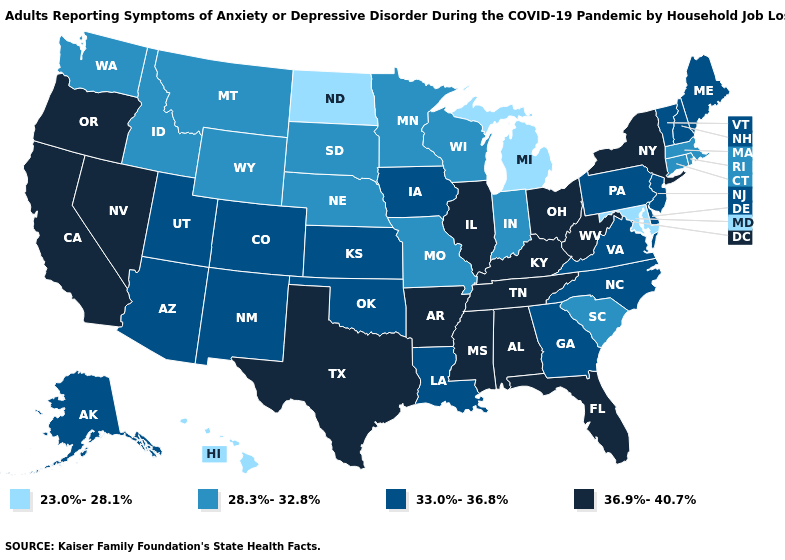Which states have the lowest value in the USA?
Quick response, please. Hawaii, Maryland, Michigan, North Dakota. What is the highest value in the South ?
Write a very short answer. 36.9%-40.7%. What is the value of New Mexico?
Keep it brief. 33.0%-36.8%. What is the value of Illinois?
Short answer required. 36.9%-40.7%. Which states hav the highest value in the West?
Quick response, please. California, Nevada, Oregon. Does Hawaii have the lowest value in the USA?
Give a very brief answer. Yes. Name the states that have a value in the range 33.0%-36.8%?
Keep it brief. Alaska, Arizona, Colorado, Delaware, Georgia, Iowa, Kansas, Louisiana, Maine, New Hampshire, New Jersey, New Mexico, North Carolina, Oklahoma, Pennsylvania, Utah, Vermont, Virginia. What is the value of Washington?
Be succinct. 28.3%-32.8%. What is the lowest value in states that border Colorado?
Keep it brief. 28.3%-32.8%. Name the states that have a value in the range 23.0%-28.1%?
Short answer required. Hawaii, Maryland, Michigan, North Dakota. Name the states that have a value in the range 36.9%-40.7%?
Be succinct. Alabama, Arkansas, California, Florida, Illinois, Kentucky, Mississippi, Nevada, New York, Ohio, Oregon, Tennessee, Texas, West Virginia. Among the states that border Washington , does Oregon have the lowest value?
Short answer required. No. Does Alaska have the highest value in the USA?
Quick response, please. No. Name the states that have a value in the range 33.0%-36.8%?
Be succinct. Alaska, Arizona, Colorado, Delaware, Georgia, Iowa, Kansas, Louisiana, Maine, New Hampshire, New Jersey, New Mexico, North Carolina, Oklahoma, Pennsylvania, Utah, Vermont, Virginia. Does Kansas have the lowest value in the USA?
Answer briefly. No. 